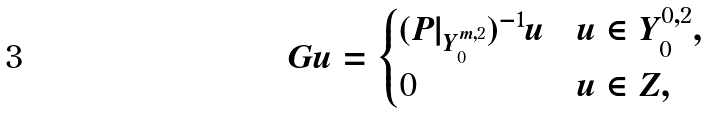<formula> <loc_0><loc_0><loc_500><loc_500>G u = \begin{cases} ( P | _ { Y ^ { m , 2 } _ { 0 } } ) ^ { - 1 } u & u \in Y ^ { 0 , 2 } _ { 0 } , \\ 0 & u \in Z , \end{cases}</formula> 